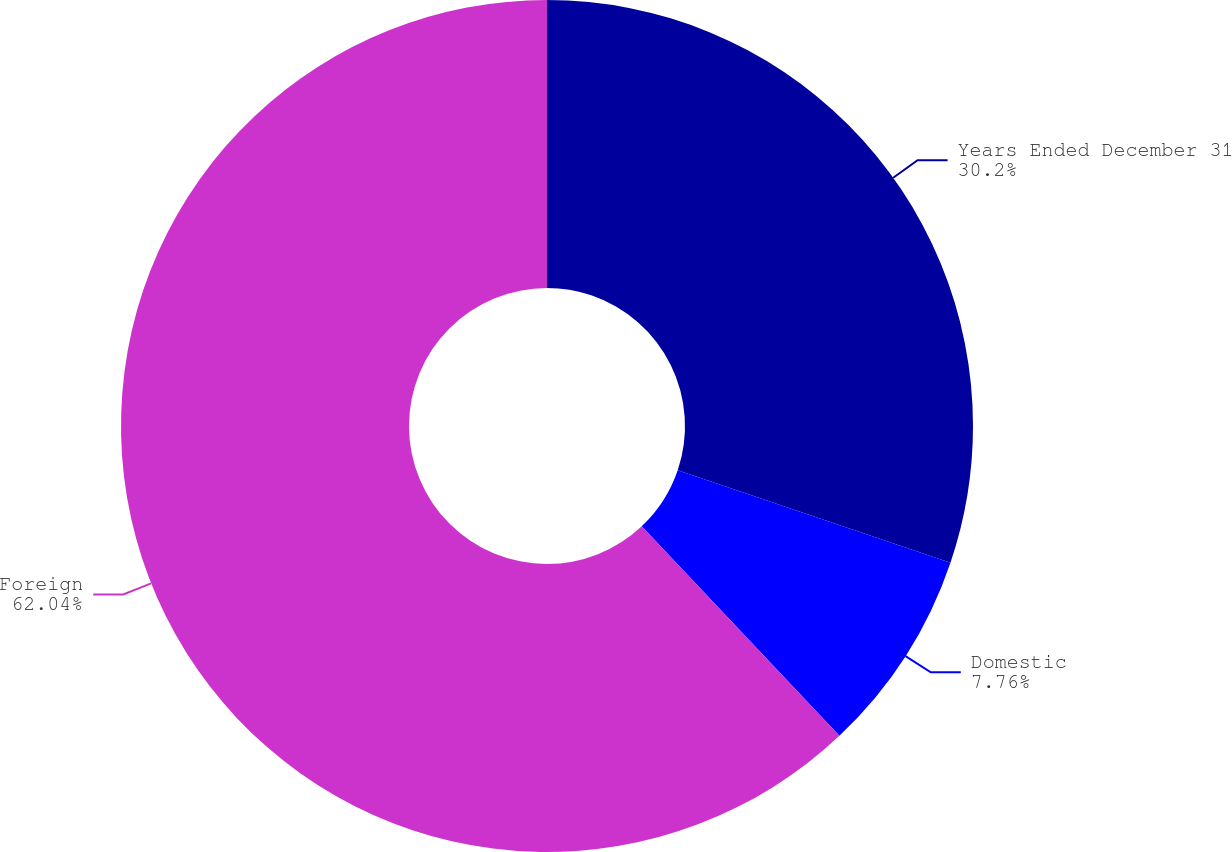<chart> <loc_0><loc_0><loc_500><loc_500><pie_chart><fcel>Years Ended December 31<fcel>Domestic<fcel>Foreign<nl><fcel>30.2%<fcel>7.76%<fcel>62.04%<nl></chart> 